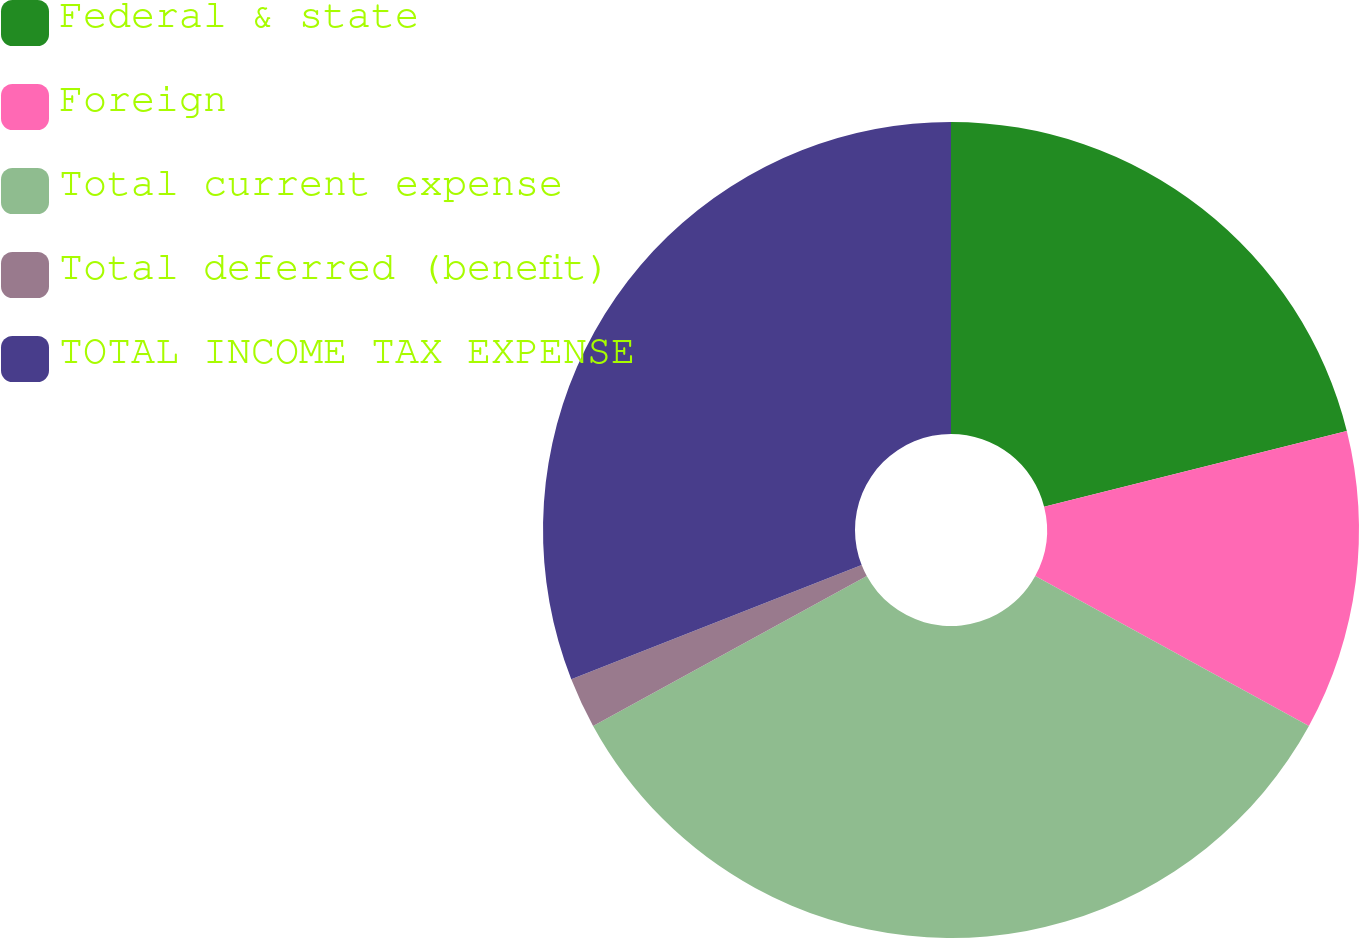Convert chart. <chart><loc_0><loc_0><loc_500><loc_500><pie_chart><fcel>Federal & state<fcel>Foreign<fcel>Total current expense<fcel>Total deferred (benefit)<fcel>TOTAL INCOME TAX EXPENSE<nl><fcel>21.1%<fcel>11.87%<fcel>34.06%<fcel>2.01%<fcel>30.96%<nl></chart> 